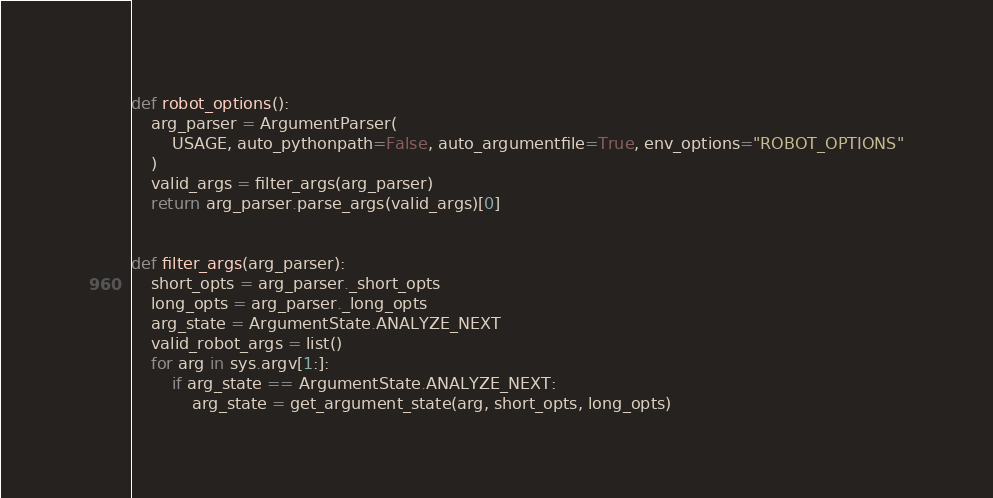Convert code to text. <code><loc_0><loc_0><loc_500><loc_500><_Python_>

def robot_options():
    arg_parser = ArgumentParser(
        USAGE, auto_pythonpath=False, auto_argumentfile=True, env_options="ROBOT_OPTIONS"
    )
    valid_args = filter_args(arg_parser)
    return arg_parser.parse_args(valid_args)[0]


def filter_args(arg_parser):
    short_opts = arg_parser._short_opts
    long_opts = arg_parser._long_opts
    arg_state = ArgumentState.ANALYZE_NEXT
    valid_robot_args = list()
    for arg in sys.argv[1:]:
        if arg_state == ArgumentState.ANALYZE_NEXT:
            arg_state = get_argument_state(arg, short_opts, long_opts)</code> 